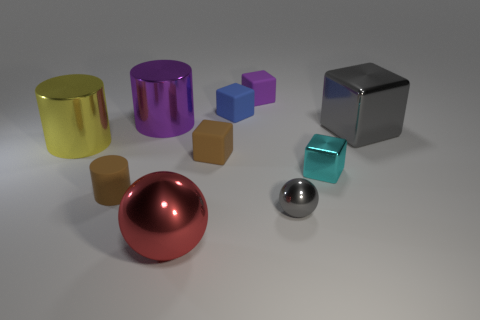How many large objects are yellow cylinders or gray metal objects?
Make the answer very short. 2. What shape is the metal thing that is the same color as the tiny shiny ball?
Offer a very short reply. Cube. Is the material of the big object right of the tiny blue rubber thing the same as the small blue block?
Your answer should be very brief. No. What material is the big cylinder that is behind the metal cube that is behind the big yellow cylinder made of?
Provide a succinct answer. Metal. How many big brown things have the same shape as the red thing?
Your answer should be very brief. 0. There is a gray shiny object that is behind the small brown object on the left side of the metallic cylinder behind the large cube; what size is it?
Provide a succinct answer. Large. How many cyan things are tiny things or big cylinders?
Provide a succinct answer. 1. There is a large purple thing behind the large yellow metallic cylinder; does it have the same shape as the blue matte object?
Keep it short and to the point. No. Are there more red metallic balls in front of the large red object than small shiny objects?
Provide a succinct answer. No. What number of cyan cubes have the same size as the red metal sphere?
Your response must be concise. 0. 